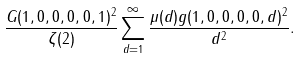Convert formula to latex. <formula><loc_0><loc_0><loc_500><loc_500>\frac { G ( 1 , 0 , 0 , 0 , 0 , 1 ) ^ { 2 } } { \zeta ( 2 ) } \sum _ { d = 1 } ^ { \infty } \frac { \mu ( d ) g ( 1 , 0 , 0 , 0 , 0 , d ) ^ { 2 } } { d ^ { 2 } } .</formula> 